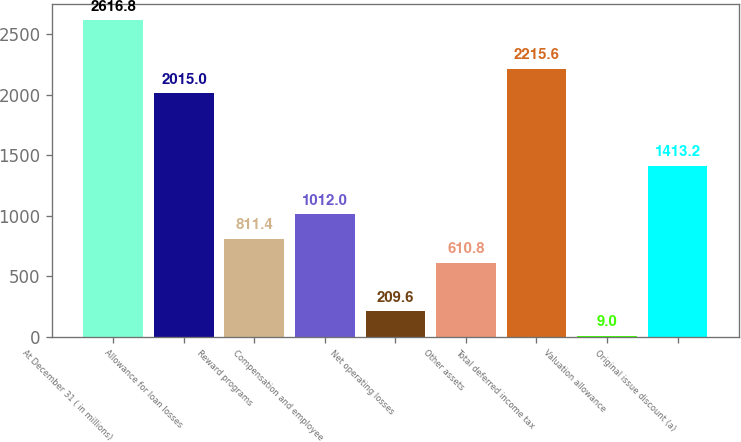<chart> <loc_0><loc_0><loc_500><loc_500><bar_chart><fcel>At December 31 ( in millions)<fcel>Allowance for loan losses<fcel>Reward programs<fcel>Compensation and employee<fcel>Net operating losses<fcel>Other assets<fcel>Total deferred income tax<fcel>Valuation allowance<fcel>Original issue discount (a)<nl><fcel>2616.8<fcel>2015<fcel>811.4<fcel>1012<fcel>209.6<fcel>610.8<fcel>2215.6<fcel>9<fcel>1413.2<nl></chart> 